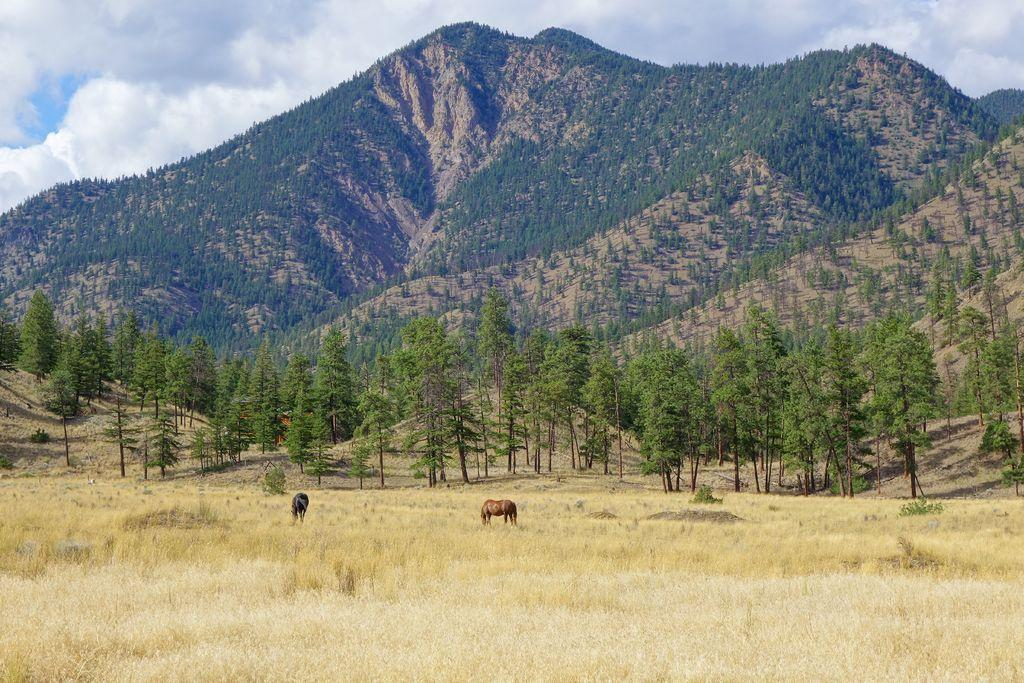What types of living organisms can be seen in the image? There are animals in the image. What can be seen in the background of the image? There are trees and mountains in the background of the image. What is the weather condition can be inferred from the sky in the image? The sky is cloudy at the top of the image, suggesting a potentially overcast or cloudy day. What type of acoustics can be heard from the animals in the image? There is no sound present in the image, so it is impossible to determine the acoustics of the animals. Is there any wound visible on the animals in the image? There is no indication of any wound on the animals in the image. 